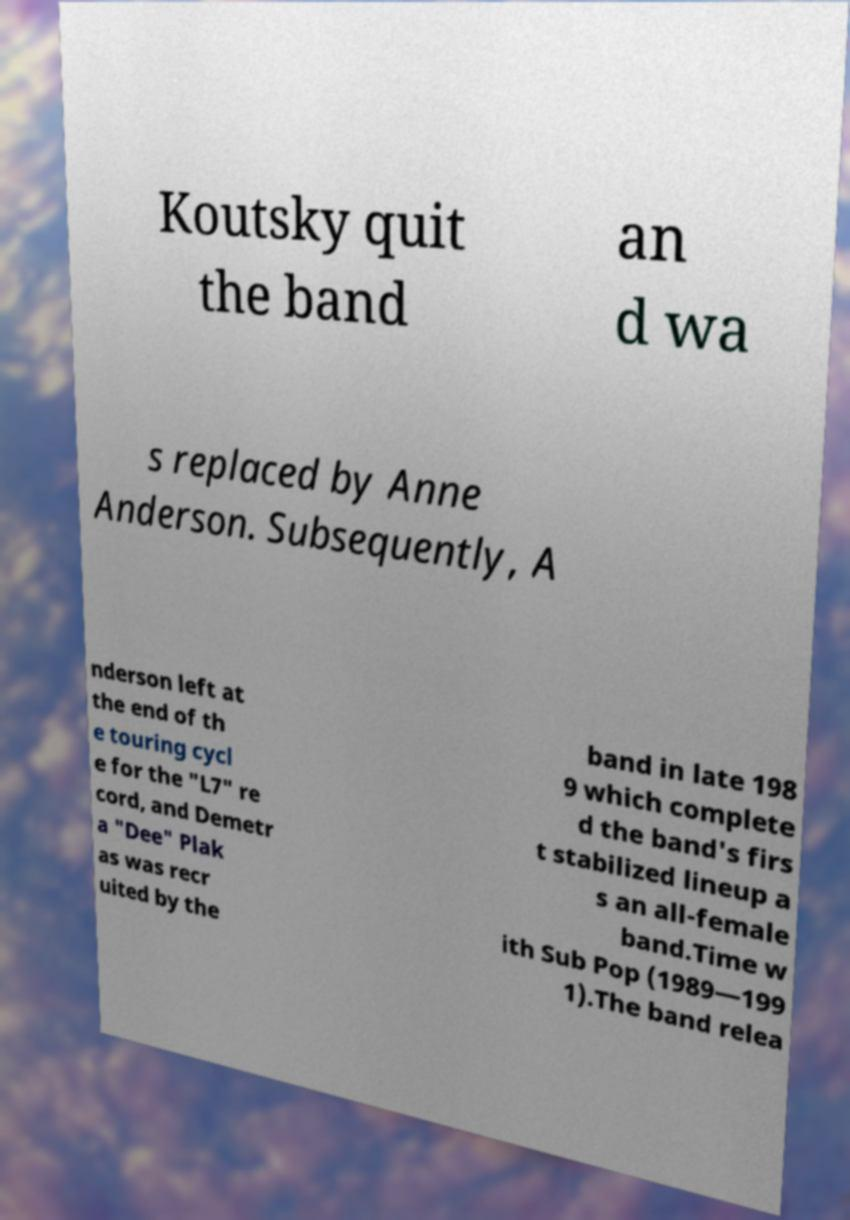Please read and relay the text visible in this image. What does it say? Koutsky quit the band an d wa s replaced by Anne Anderson. Subsequently, A nderson left at the end of th e touring cycl e for the "L7" re cord, and Demetr a "Dee" Plak as was recr uited by the band in late 198 9 which complete d the band's firs t stabilized lineup a s an all-female band.Time w ith Sub Pop (1989—199 1).The band relea 